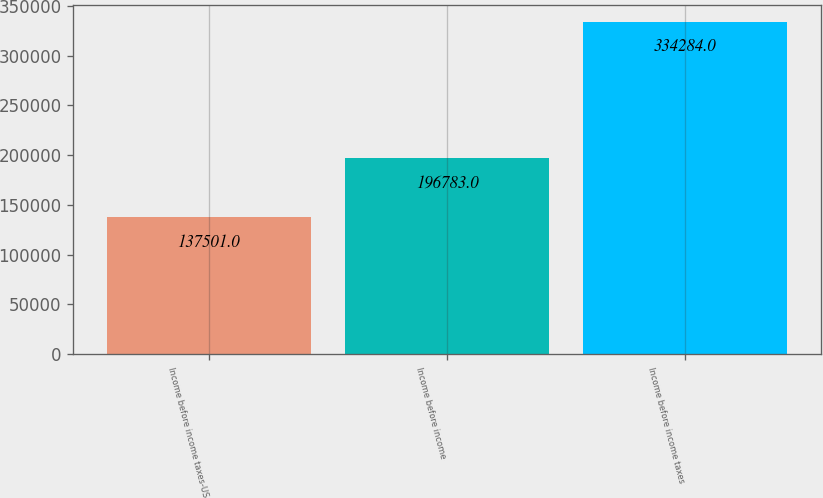Convert chart. <chart><loc_0><loc_0><loc_500><loc_500><bar_chart><fcel>Income before income taxes-US<fcel>Income before income<fcel>Income before income taxes<nl><fcel>137501<fcel>196783<fcel>334284<nl></chart> 